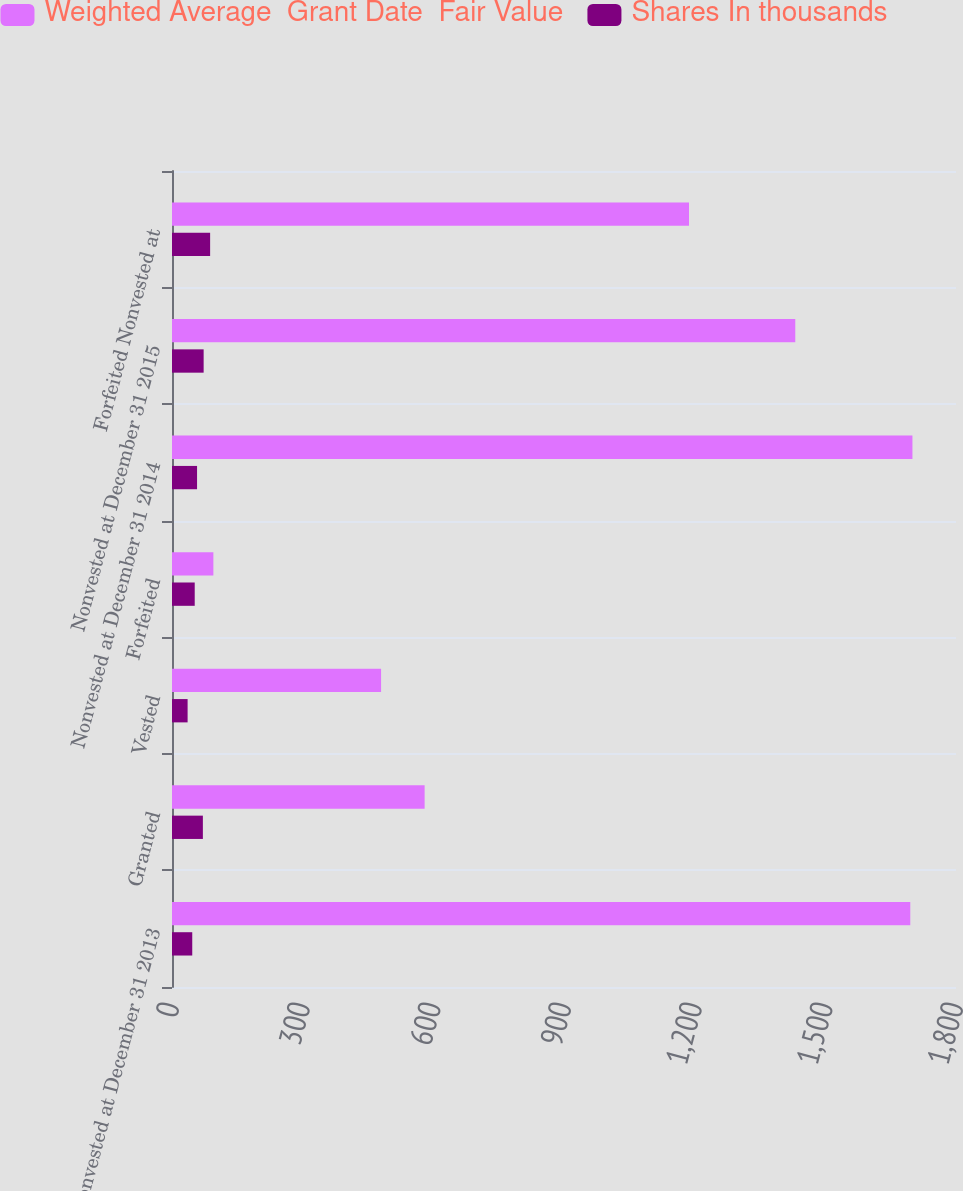<chart> <loc_0><loc_0><loc_500><loc_500><stacked_bar_chart><ecel><fcel>Nonvested at December 31 2013<fcel>Granted<fcel>Vested<fcel>Forfeited<fcel>Nonvested at December 31 2014<fcel>Nonvested at December 31 2015<fcel>Forfeited Nonvested at<nl><fcel>Weighted Average  Grant Date  Fair Value<fcel>1695<fcel>580<fcel>480<fcel>95<fcel>1700<fcel>1431<fcel>1187<nl><fcel>Shares In thousands<fcel>46.5<fcel>70.89<fcel>35.83<fcel>52.16<fcel>57.52<fcel>72.64<fcel>87.54<nl></chart> 